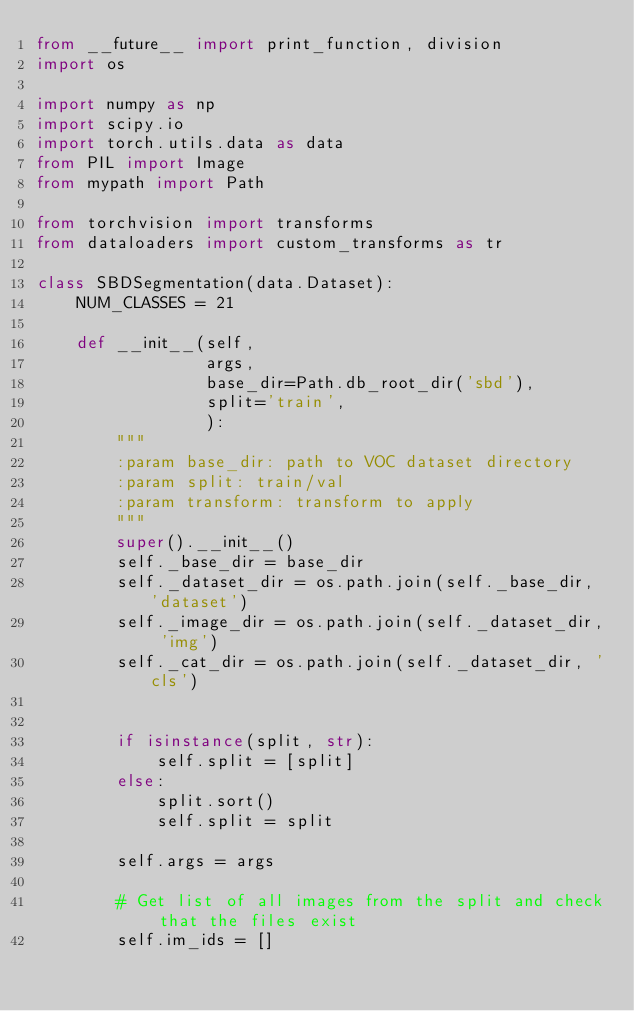Convert code to text. <code><loc_0><loc_0><loc_500><loc_500><_Python_>from __future__ import print_function, division
import os

import numpy as np
import scipy.io
import torch.utils.data as data
from PIL import Image
from mypath import Path

from torchvision import transforms
from dataloaders import custom_transforms as tr

class SBDSegmentation(data.Dataset):
    NUM_CLASSES = 21

    def __init__(self,
                 args,
                 base_dir=Path.db_root_dir('sbd'),
                 split='train',
                 ):
        """
        :param base_dir: path to VOC dataset directory
        :param split: train/val
        :param transform: transform to apply
        """
        super().__init__()
        self._base_dir = base_dir
        self._dataset_dir = os.path.join(self._base_dir, 'dataset')
        self._image_dir = os.path.join(self._dataset_dir, 'img')
        self._cat_dir = os.path.join(self._dataset_dir, 'cls')


        if isinstance(split, str):
            self.split = [split]
        else:
            split.sort()
            self.split = split

        self.args = args

        # Get list of all images from the split and check that the files exist
        self.im_ids = []</code> 